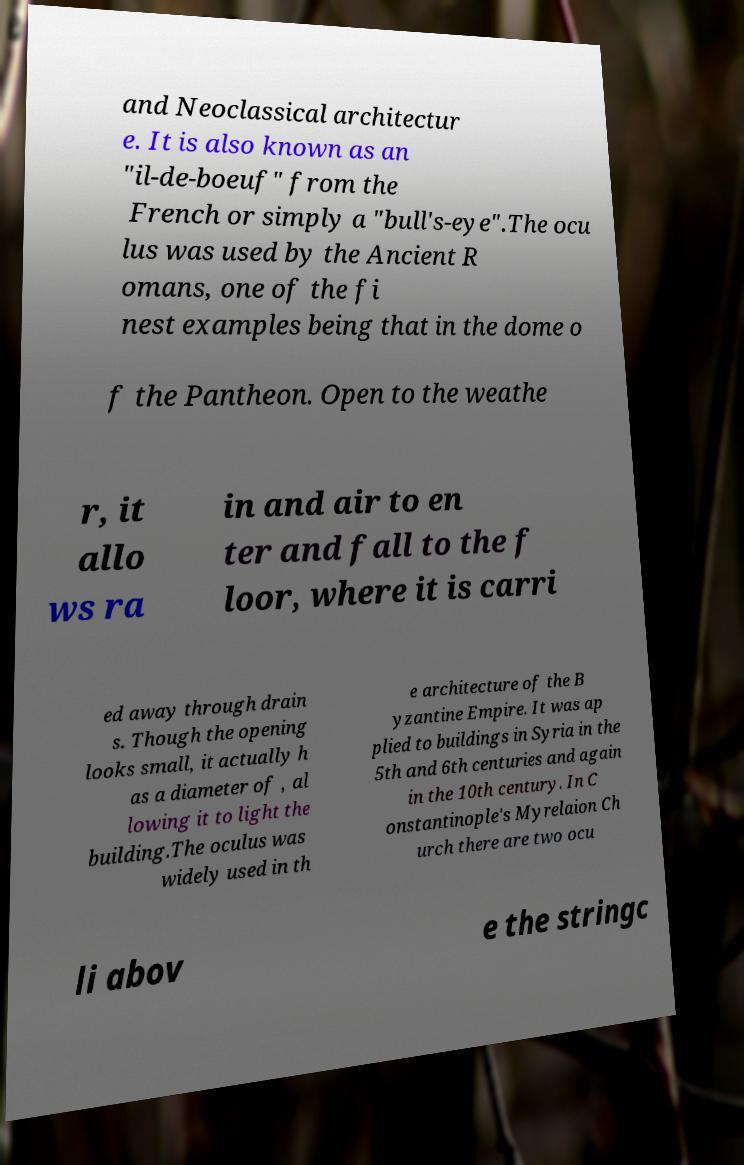I need the written content from this picture converted into text. Can you do that? and Neoclassical architectur e. It is also known as an "il-de-boeuf" from the French or simply a "bull's-eye".The ocu lus was used by the Ancient R omans, one of the fi nest examples being that in the dome o f the Pantheon. Open to the weathe r, it allo ws ra in and air to en ter and fall to the f loor, where it is carri ed away through drain s. Though the opening looks small, it actually h as a diameter of , al lowing it to light the building.The oculus was widely used in th e architecture of the B yzantine Empire. It was ap plied to buildings in Syria in the 5th and 6th centuries and again in the 10th century. In C onstantinople's Myrelaion Ch urch there are two ocu li abov e the stringc 